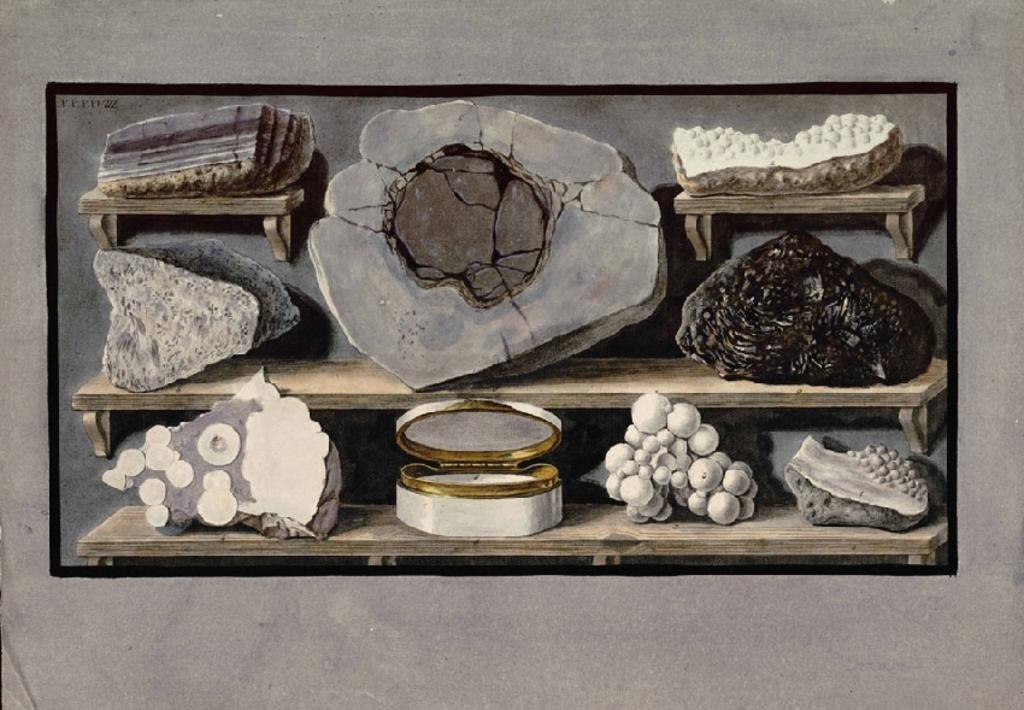What is present on the wall in the image? There is a poster in the image. What is depicted on the poster? The poster contains images of stones and boxwoods on racks. Where is the poster located in the image? The poster is placed on a wall. What type of worm can be seen crawling on the poster in the image? There are no worms present on the poster in the image. 